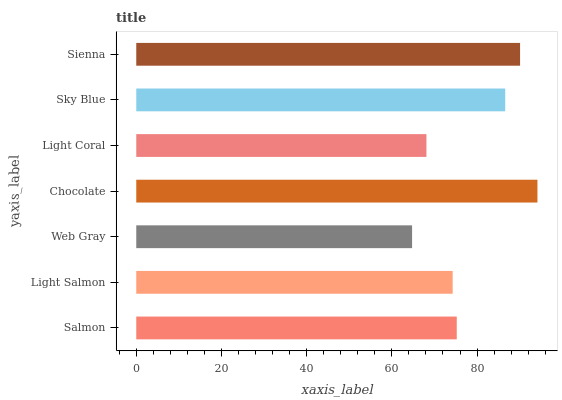Is Web Gray the minimum?
Answer yes or no. Yes. Is Chocolate the maximum?
Answer yes or no. Yes. Is Light Salmon the minimum?
Answer yes or no. No. Is Light Salmon the maximum?
Answer yes or no. No. Is Salmon greater than Light Salmon?
Answer yes or no. Yes. Is Light Salmon less than Salmon?
Answer yes or no. Yes. Is Light Salmon greater than Salmon?
Answer yes or no. No. Is Salmon less than Light Salmon?
Answer yes or no. No. Is Salmon the high median?
Answer yes or no. Yes. Is Salmon the low median?
Answer yes or no. Yes. Is Sky Blue the high median?
Answer yes or no. No. Is Web Gray the low median?
Answer yes or no. No. 